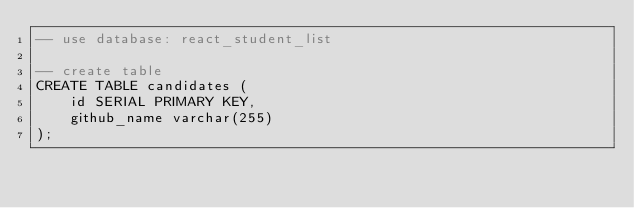Convert code to text. <code><loc_0><loc_0><loc_500><loc_500><_SQL_>-- use database: react_student_list

-- create table
CREATE TABLE candidates (
	id SERIAL PRIMARY KEY,
	github_name varchar(255)
);</code> 